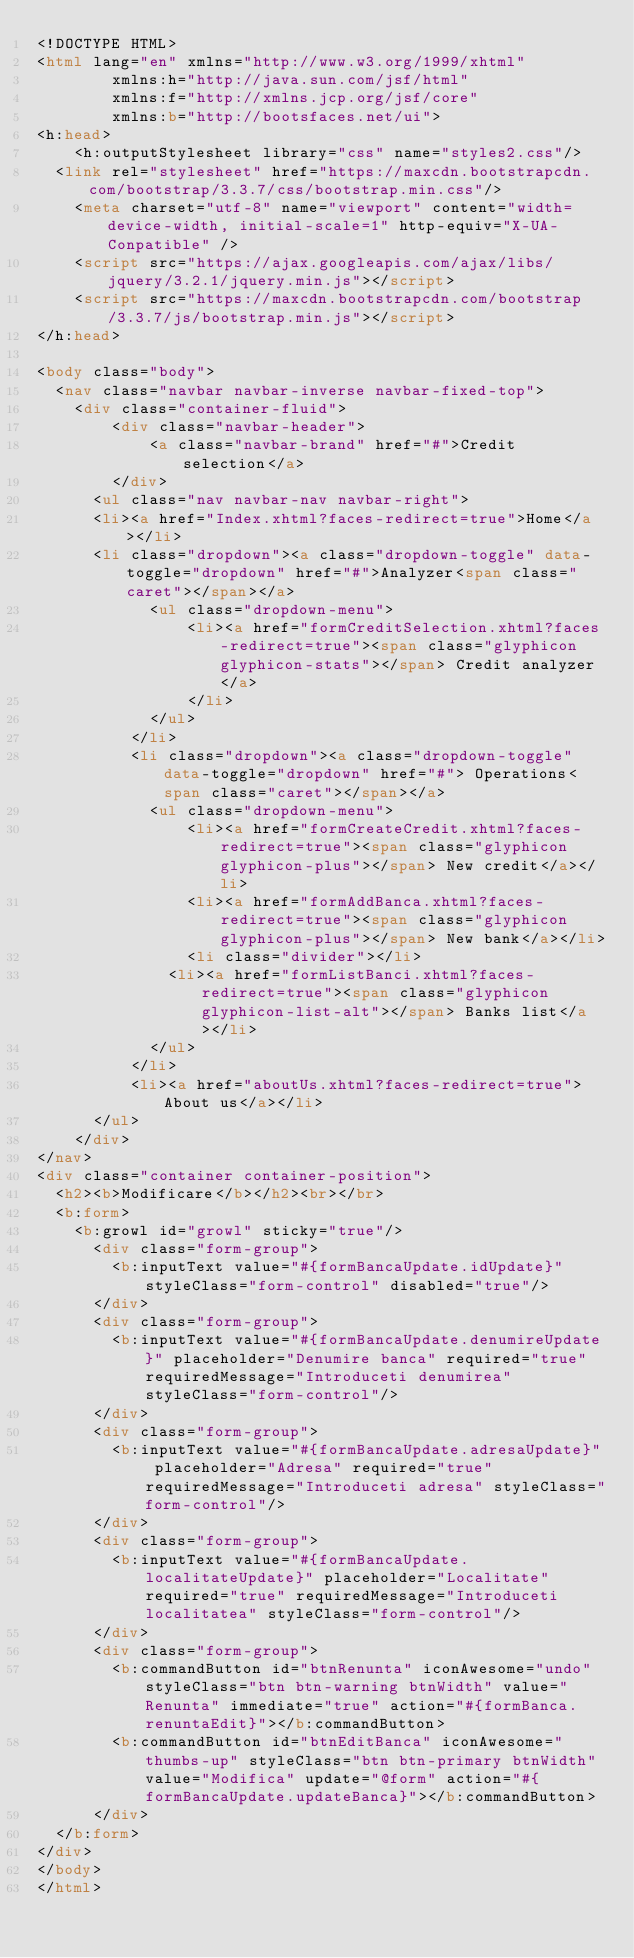<code> <loc_0><loc_0><loc_500><loc_500><_HTML_><!DOCTYPE HTML>
<html lang="en" xmlns="http://www.w3.org/1999/xhtml" 
				xmlns:h="http://java.sun.com/jsf/html" 
				xmlns:f="http://xmlns.jcp.org/jsf/core"
				xmlns:b="http://bootsfaces.net/ui">
<h:head>
    <h:outputStylesheet library="css" name="styles2.css"/>
	<link rel="stylesheet" href="https://maxcdn.bootstrapcdn.com/bootstrap/3.3.7/css/bootstrap.min.css"/>
    <meta charset="utf-8" name="viewport" content="width=device-width, initial-scale=1" http-equiv="X-UA-Conpatible" />
    <script src="https://ajax.googleapis.com/ajax/libs/jquery/3.2.1/jquery.min.js"></script>
    <script src="https://maxcdn.bootstrapcdn.com/bootstrap/3.3.7/js/bootstrap.min.js"></script>  
</h:head>

<body class="body">
 	<nav class="navbar navbar-inverse navbar-fixed-top">
 	 	<div class="container-fluid">
    		<div class="navbar-header">
      			<a class="navbar-brand" href="#">Credit selection</a>
    		</div>
    	<ul class="nav navbar-nav navbar-right">
			<li><a href="Index.xhtml?faces-redirect=true">Home</a></li>
			<li class="dropdown"><a class="dropdown-toggle" data-toggle="dropdown" href="#">Analyzer<span class="caret"></span></a>
        		<ul class="dropdown-menu">
	          		<li><a href="formCreditSelection.xhtml?faces-redirect=true"><span class="glyphicon glyphicon-stats"></span> Credit analyzer</a>
	          		</li>
	        	</ul>
      		</li>
      	 	<li class="dropdown"><a class="dropdown-toggle" data-toggle="dropdown" href="#"> Operations<span class="caret"></span></a>
	        	<ul class="dropdown-menu">
	          		<li><a href="formCreateCredit.xhtml?faces-redirect=true"><span class="glyphicon glyphicon-plus"></span> New credit</a></li>
	          		<li><a href="formAddBanca.xhtml?faces-redirect=true"><span class="glyphicon glyphicon-plus"></span> New bank</a></li>
	          		<li class="divider"></li>
	         	 	<li><a href="formListBanci.xhtml?faces-redirect=true"><span class="glyphicon glyphicon-list-alt"></span> Banks list</a></li>      
	        	</ul>
      		</li>
      		<li><a href="aboutUs.xhtml?faces-redirect=true">About us</a></li>
   	 	</ul>
  	</div>
</nav>
<div class="container container-position">
	<h2><b>Modificare</b></h2><br></br>
	<b:form>
		<b:growl id="growl" sticky="true"/>
			<div class="form-group">
				<b:inputText value="#{formBancaUpdate.idUpdate}" styleClass="form-control" disabled="true"/>
			</div>
			<div class="form-group">
				<b:inputText value="#{formBancaUpdate.denumireUpdate}" placeholder="Denumire banca" required="true" requiredMessage="Introduceti denumirea" styleClass="form-control"/>
			</div>
			<div class="form-group">
				<b:inputText value="#{formBancaUpdate.adresaUpdate}" placeholder="Adresa" required="true" requiredMessage="Introduceti adresa" styleClass="form-control"/>		
			</div>
			<div class="form-group">
				<b:inputText value="#{formBancaUpdate.localitateUpdate}" placeholder="Localitate" required="true" requiredMessage="Introduceti localitatea" styleClass="form-control"/>
			</div>
			<div class="form-group">
				<b:commandButton id="btnRenunta" iconAwesome="undo" styleClass="btn btn-warning btnWidth" value="Renunta" immediate="true" action="#{formBanca.renuntaEdit}"></b:commandButton>	
				<b:commandButton id="btnEditBanca" iconAwesome="thumbs-up" styleClass="btn btn-primary btnWidth" value="Modifica" update="@form" action="#{formBancaUpdate.updateBanca}"></b:commandButton>
			</div>			
	</b:form>
</div>
</body>
</html></code> 